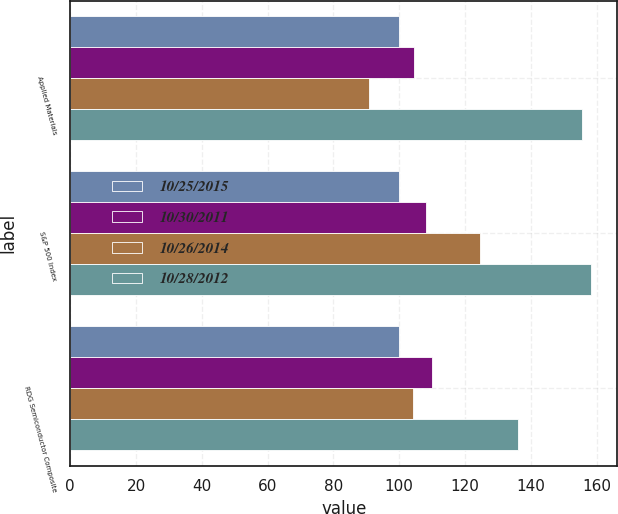Convert chart. <chart><loc_0><loc_0><loc_500><loc_500><stacked_bar_chart><ecel><fcel>Applied Materials<fcel>S&P 500 Index<fcel>RDG Semiconductor Composite<nl><fcel>10/25/2015<fcel>100<fcel>100<fcel>100<nl><fcel>10/30/2011<fcel>104.54<fcel>108.09<fcel>110.04<nl><fcel>10/26/2014<fcel>90.88<fcel>124.52<fcel>104.07<nl><fcel>10/28/2012<fcel>155.43<fcel>158.36<fcel>136.15<nl></chart> 